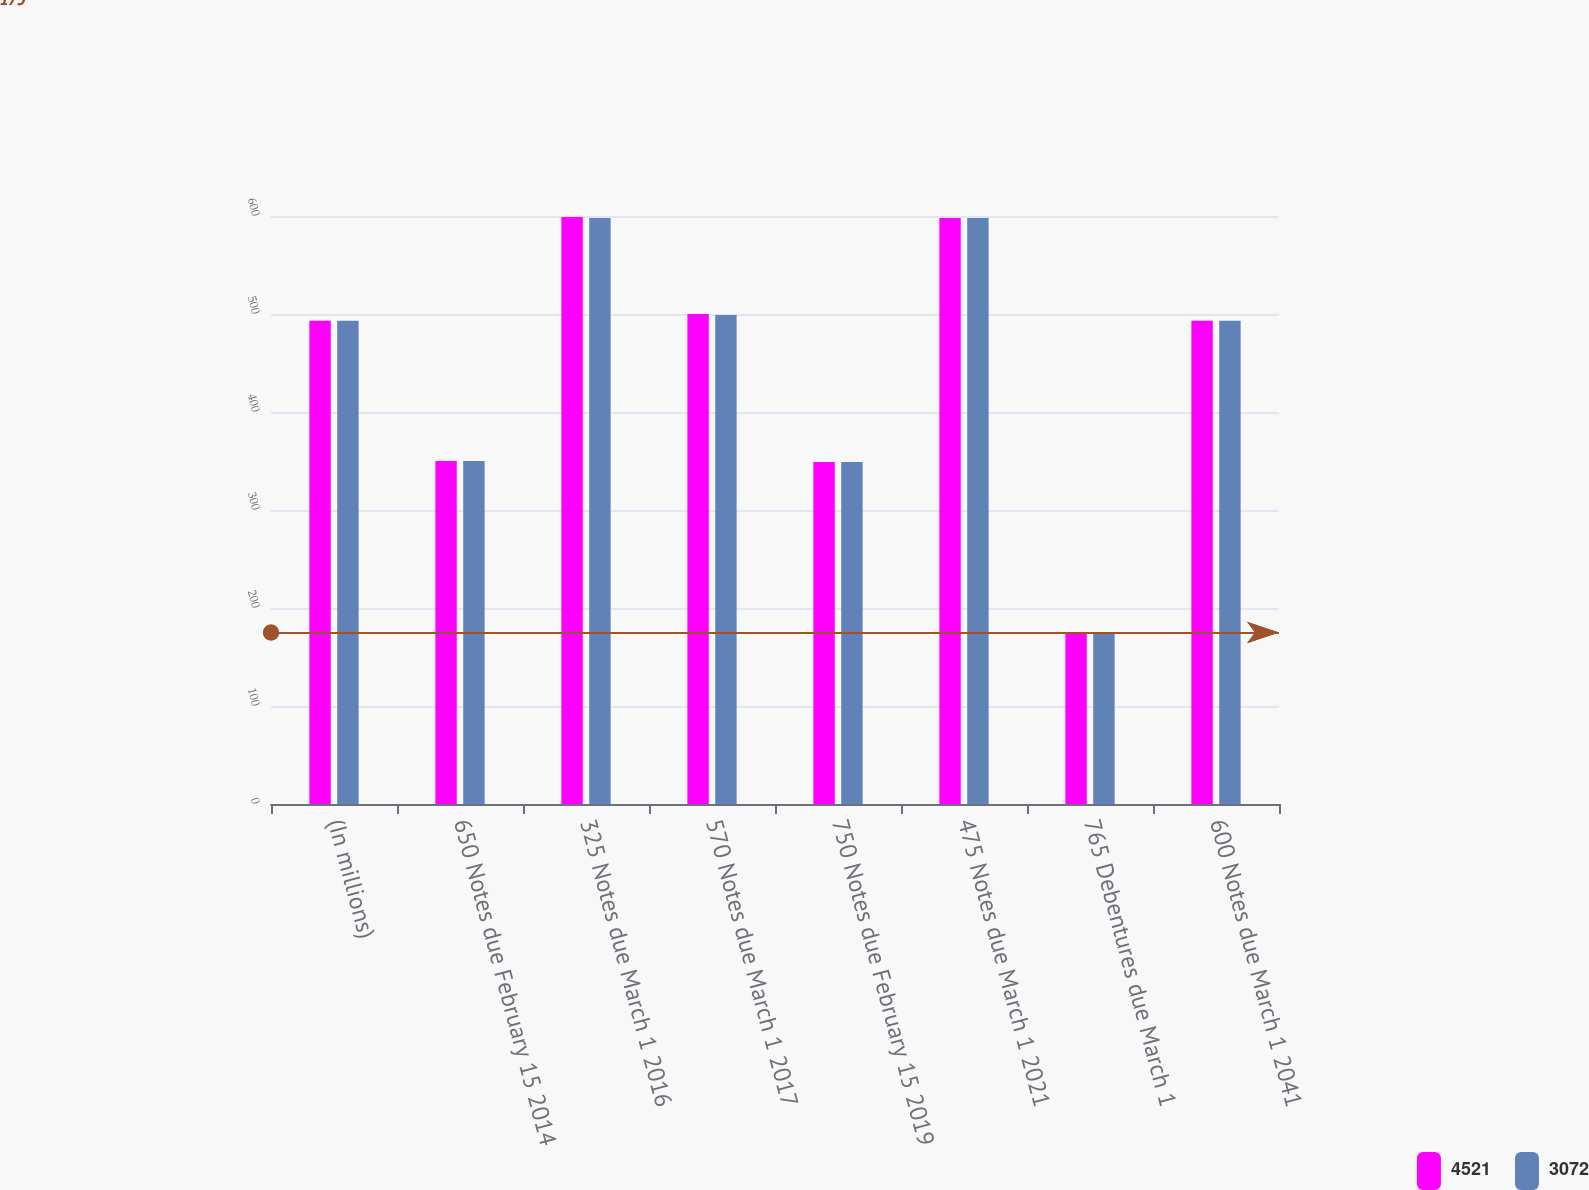Convert chart. <chart><loc_0><loc_0><loc_500><loc_500><stacked_bar_chart><ecel><fcel>(In millions)<fcel>650 Notes due February 15 2014<fcel>325 Notes due March 1 2016<fcel>570 Notes due March 1 2017<fcel>750 Notes due February 15 2019<fcel>475 Notes due March 1 2021<fcel>765 Debentures due March 1<fcel>600 Notes due March 1 2041<nl><fcel>4521<fcel>493<fcel>350<fcel>599<fcel>500<fcel>349<fcel>598<fcel>175<fcel>493<nl><fcel>3072<fcel>493<fcel>350<fcel>598<fcel>499<fcel>349<fcel>598<fcel>175<fcel>493<nl></chart> 